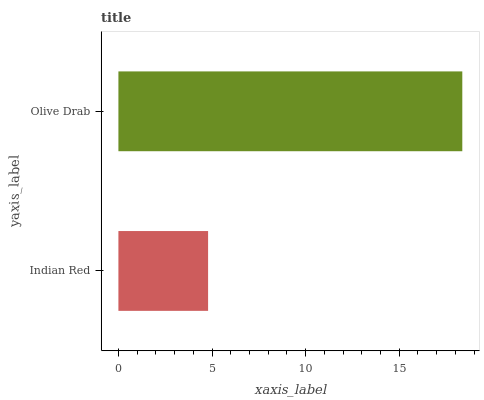Is Indian Red the minimum?
Answer yes or no. Yes. Is Olive Drab the maximum?
Answer yes or no. Yes. Is Olive Drab the minimum?
Answer yes or no. No. Is Olive Drab greater than Indian Red?
Answer yes or no. Yes. Is Indian Red less than Olive Drab?
Answer yes or no. Yes. Is Indian Red greater than Olive Drab?
Answer yes or no. No. Is Olive Drab less than Indian Red?
Answer yes or no. No. Is Olive Drab the high median?
Answer yes or no. Yes. Is Indian Red the low median?
Answer yes or no. Yes. Is Indian Red the high median?
Answer yes or no. No. Is Olive Drab the low median?
Answer yes or no. No. 